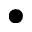Convert formula to latex. <formula><loc_0><loc_0><loc_500><loc_500>\bullet</formula> 